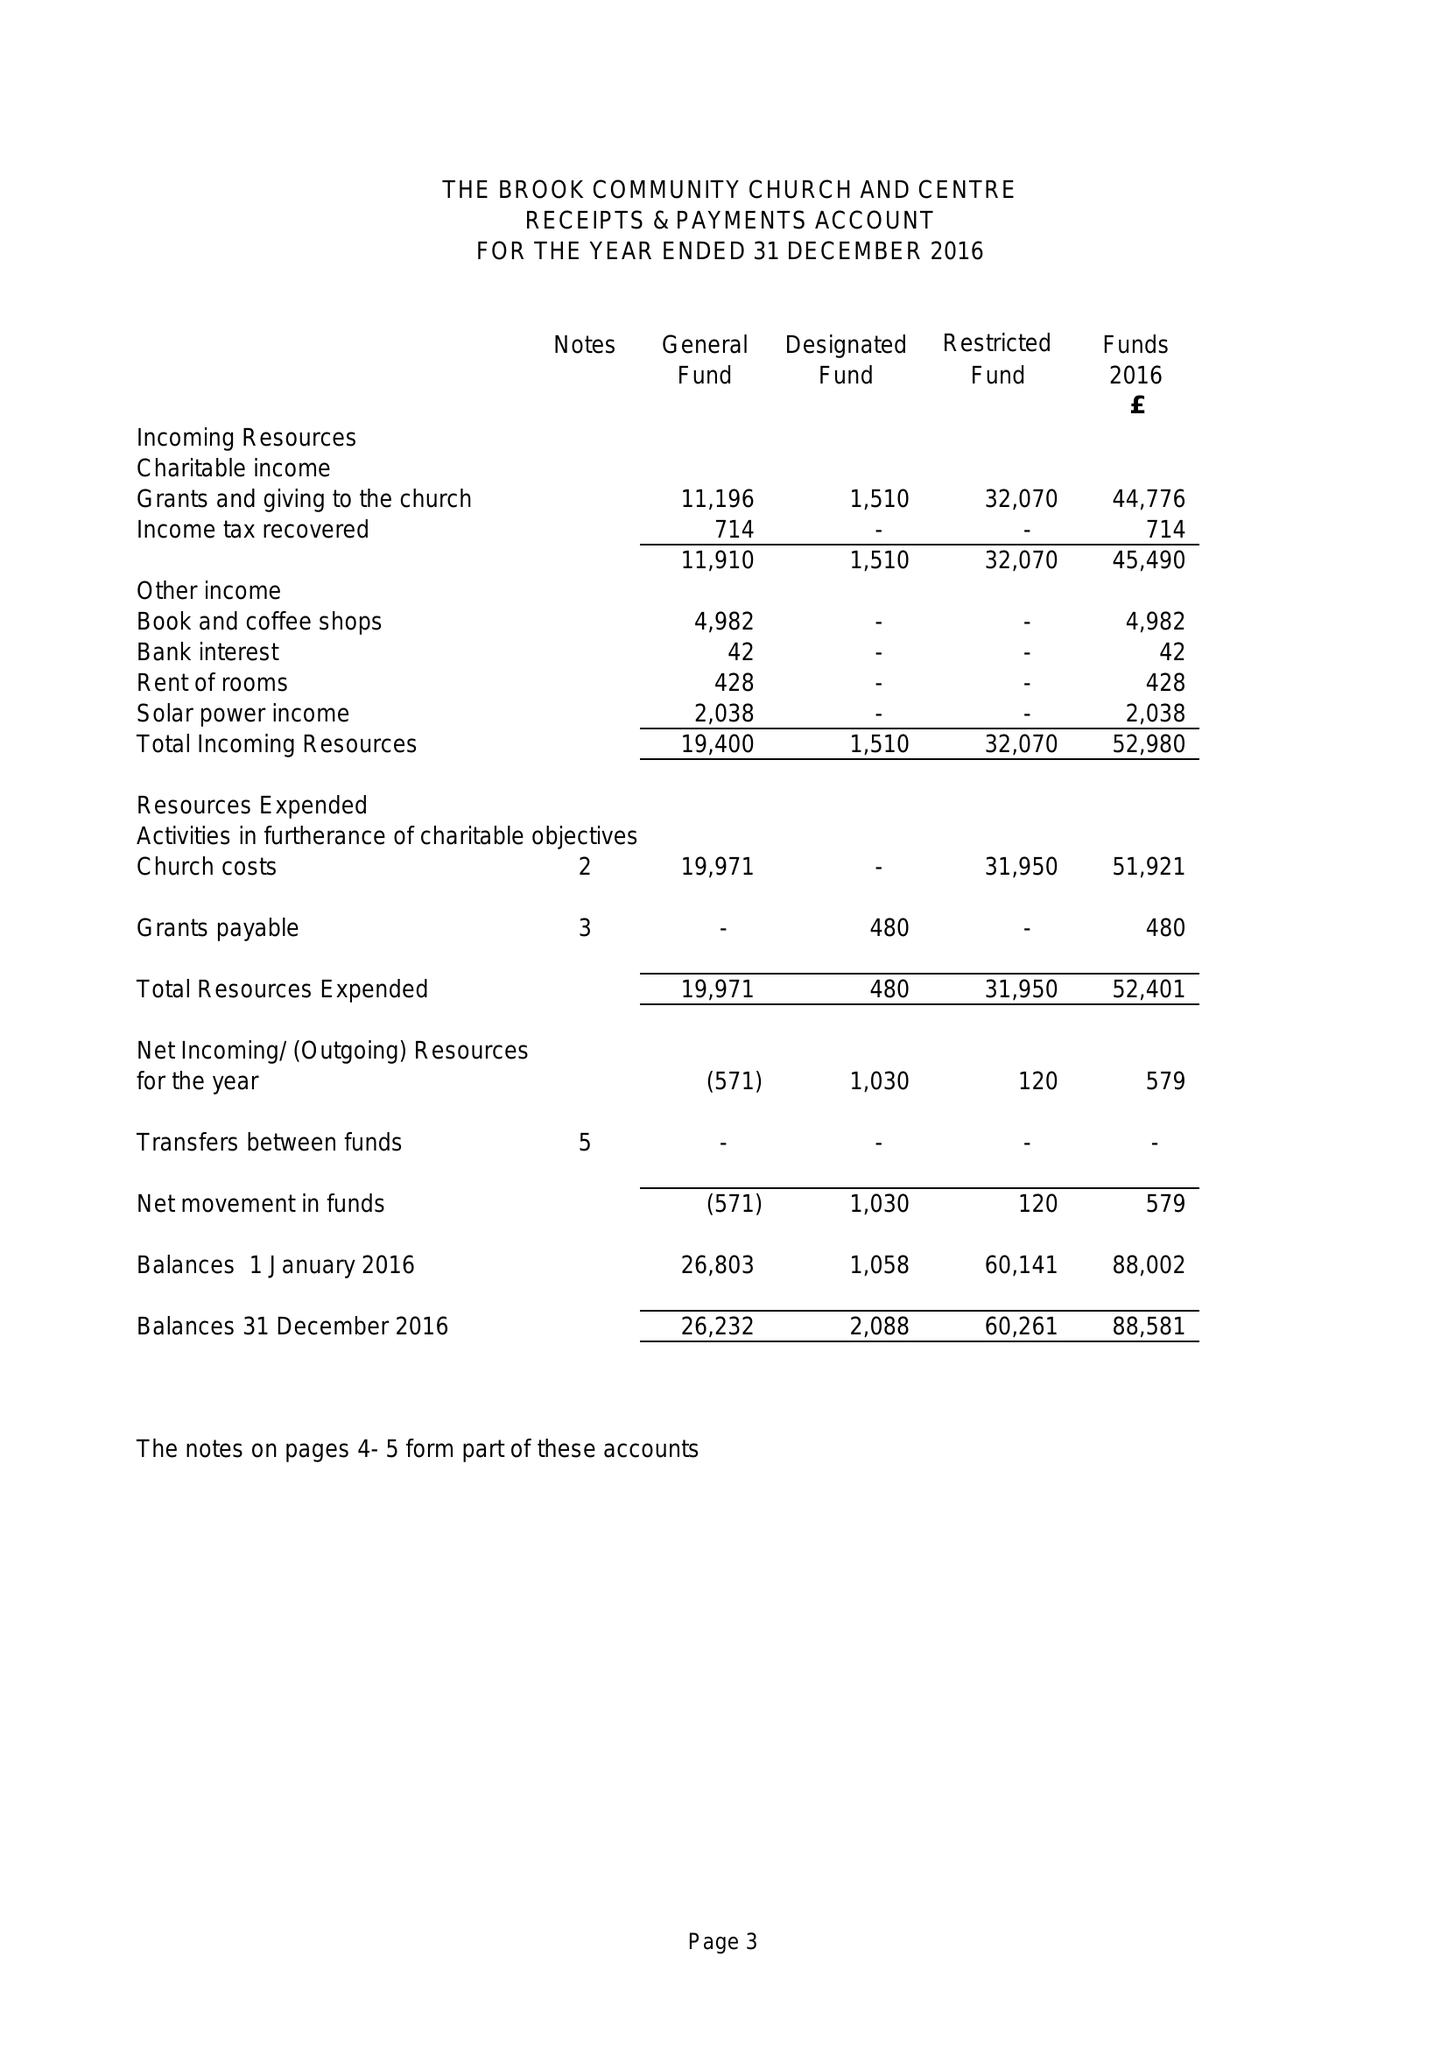What is the value for the charity_name?
Answer the question using a single word or phrase. The Brook Community Church and Centre 